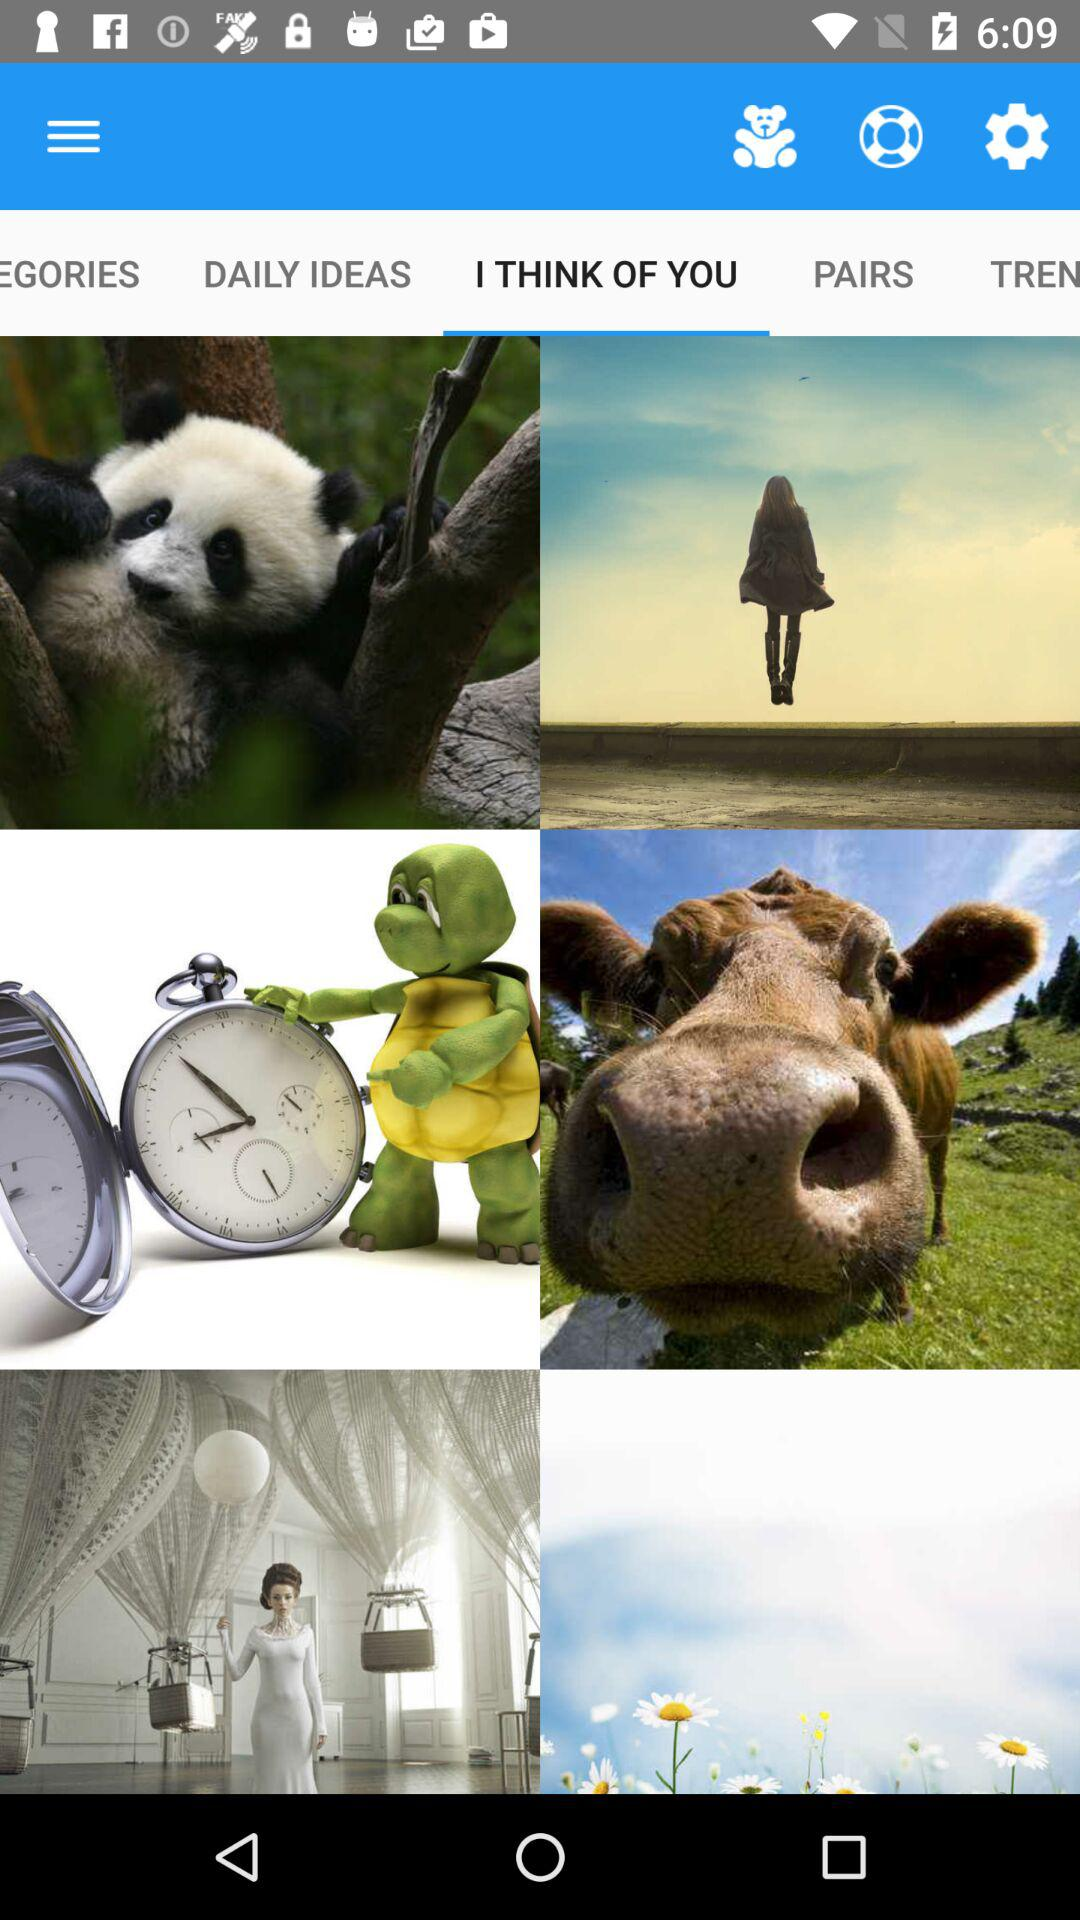Which option is selected? The selected option is "I THINK OF YOU". 